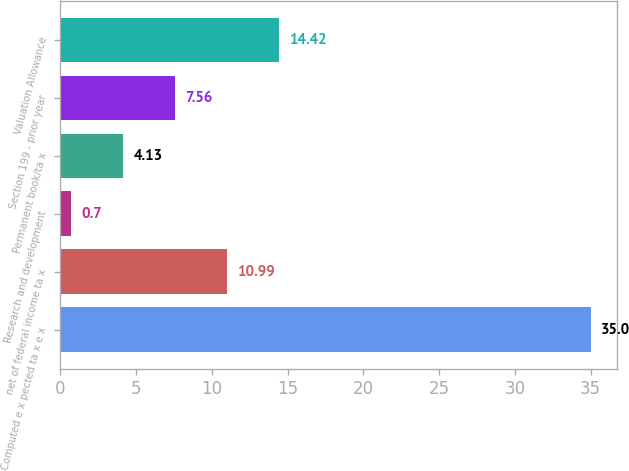Convert chart. <chart><loc_0><loc_0><loc_500><loc_500><bar_chart><fcel>Computed e x pected ta x e x<fcel>net of federal income ta x<fcel>Research and development<fcel>Permanent book/ta x<fcel>Section 199 - prior year<fcel>Valuation Allowance<nl><fcel>35<fcel>10.99<fcel>0.7<fcel>4.13<fcel>7.56<fcel>14.42<nl></chart> 